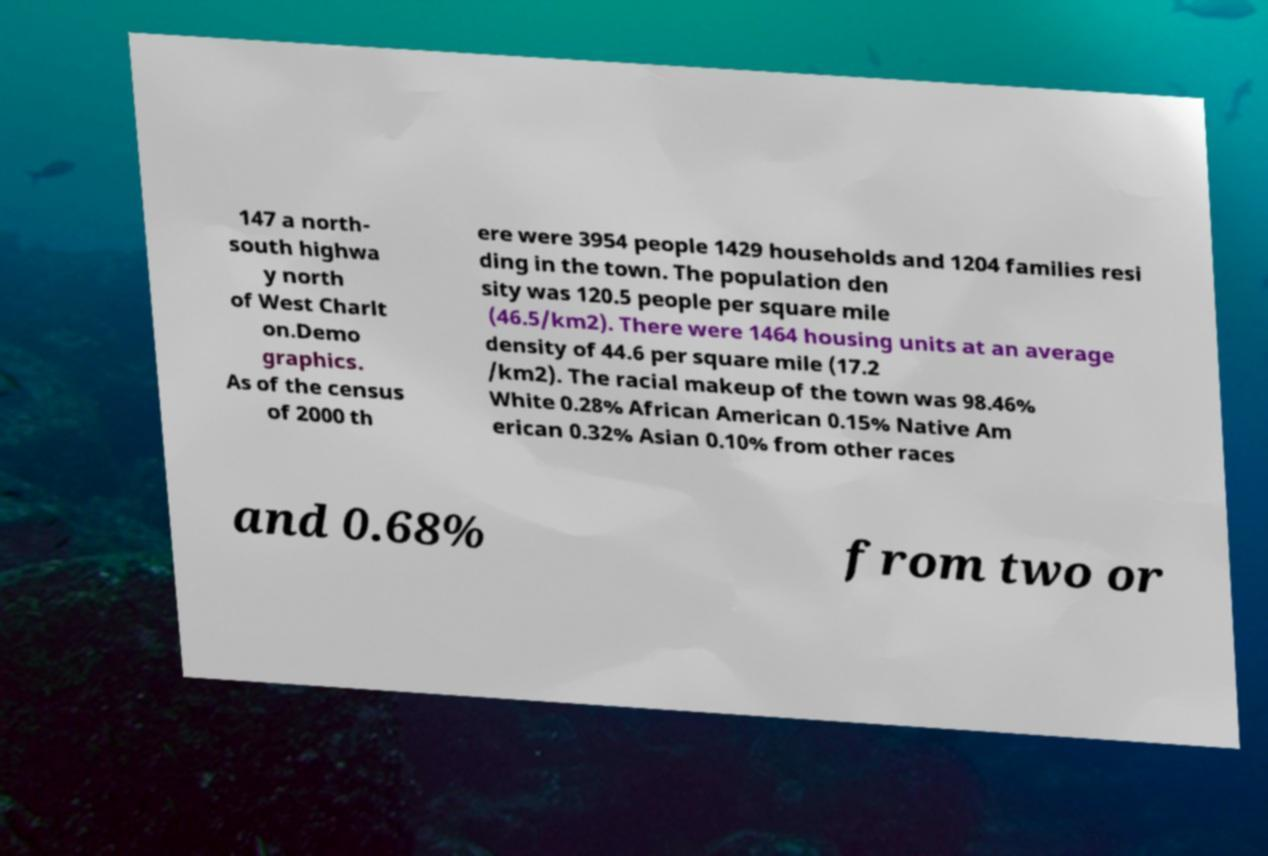Can you read and provide the text displayed in the image?This photo seems to have some interesting text. Can you extract and type it out for me? 147 a north- south highwa y north of West Charlt on.Demo graphics. As of the census of 2000 th ere were 3954 people 1429 households and 1204 families resi ding in the town. The population den sity was 120.5 people per square mile (46.5/km2). There were 1464 housing units at an average density of 44.6 per square mile (17.2 /km2). The racial makeup of the town was 98.46% White 0.28% African American 0.15% Native Am erican 0.32% Asian 0.10% from other races and 0.68% from two or 